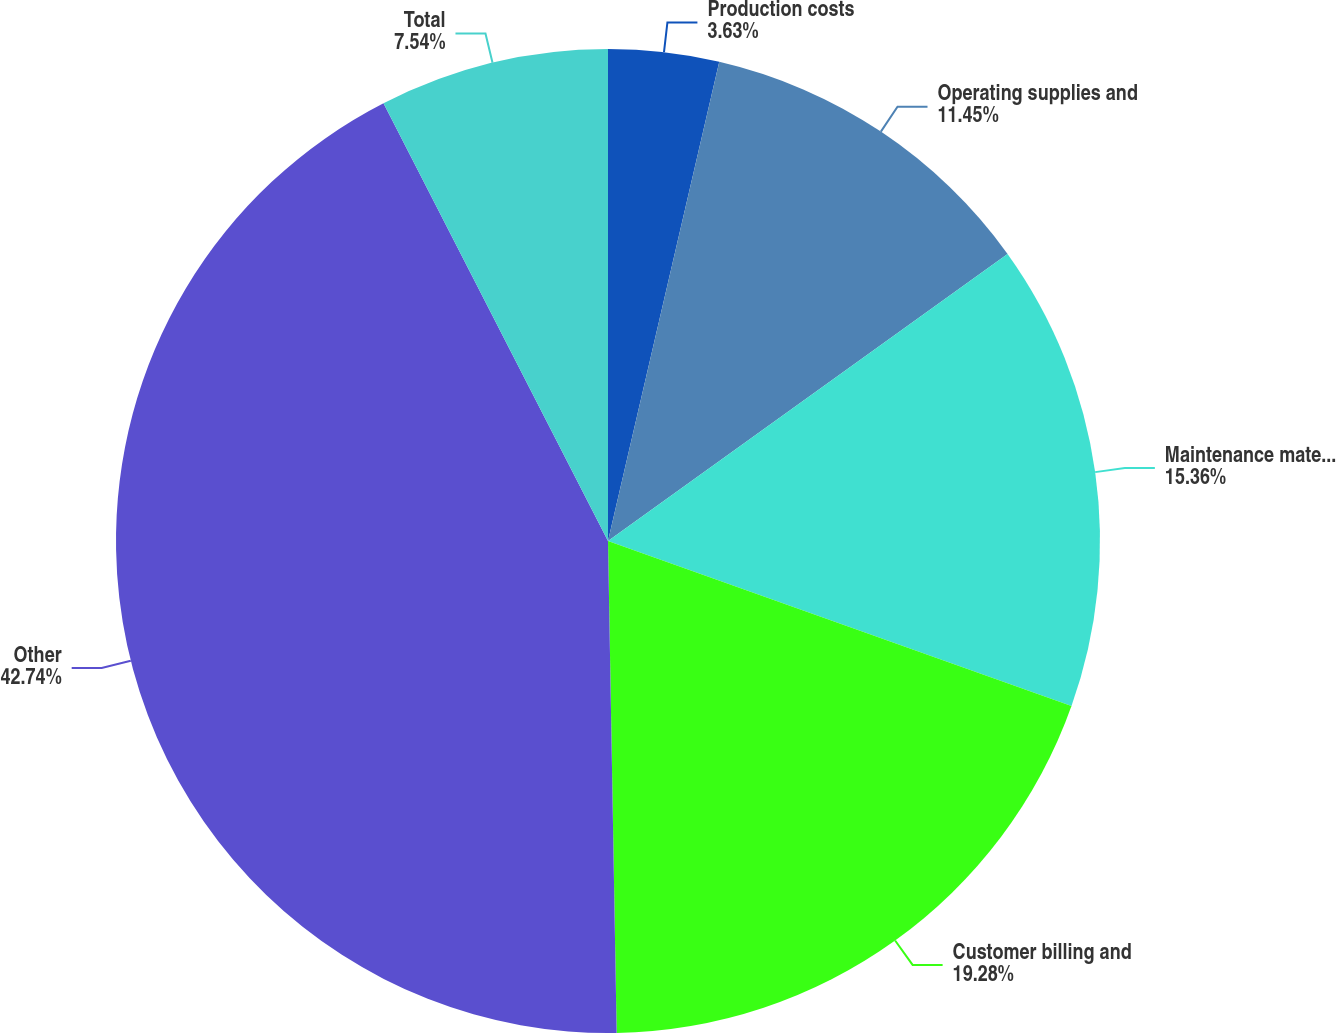Convert chart to OTSL. <chart><loc_0><loc_0><loc_500><loc_500><pie_chart><fcel>Production costs<fcel>Operating supplies and<fcel>Maintenance materials and<fcel>Customer billing and<fcel>Other<fcel>Total<nl><fcel>3.63%<fcel>11.45%<fcel>15.36%<fcel>19.27%<fcel>42.73%<fcel>7.54%<nl></chart> 